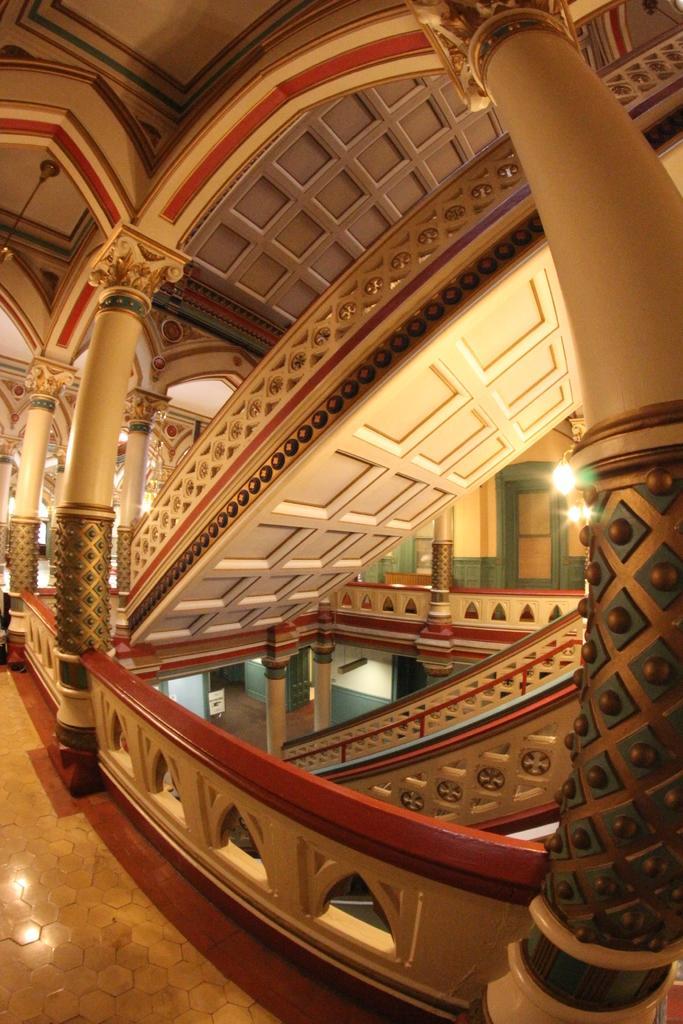Can you describe this image briefly? This picture describes about inside view of a building, in this we can find few lights. 